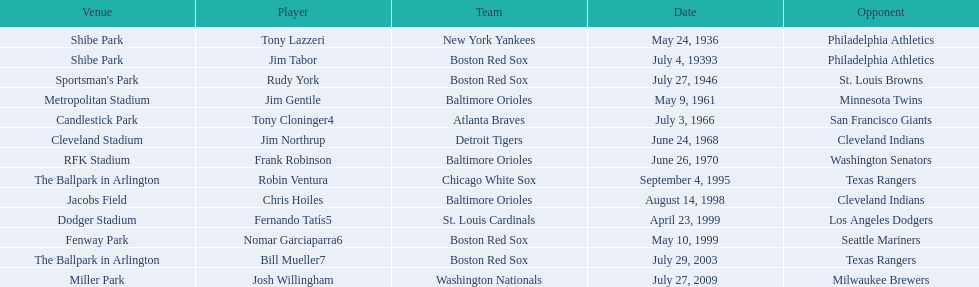Who are the opponents of the boston red sox during baseball home run records? Philadelphia Athletics, St. Louis Browns, Seattle Mariners, Texas Rangers. Of those which was the opponent on july 27, 1946? St. Louis Browns. 